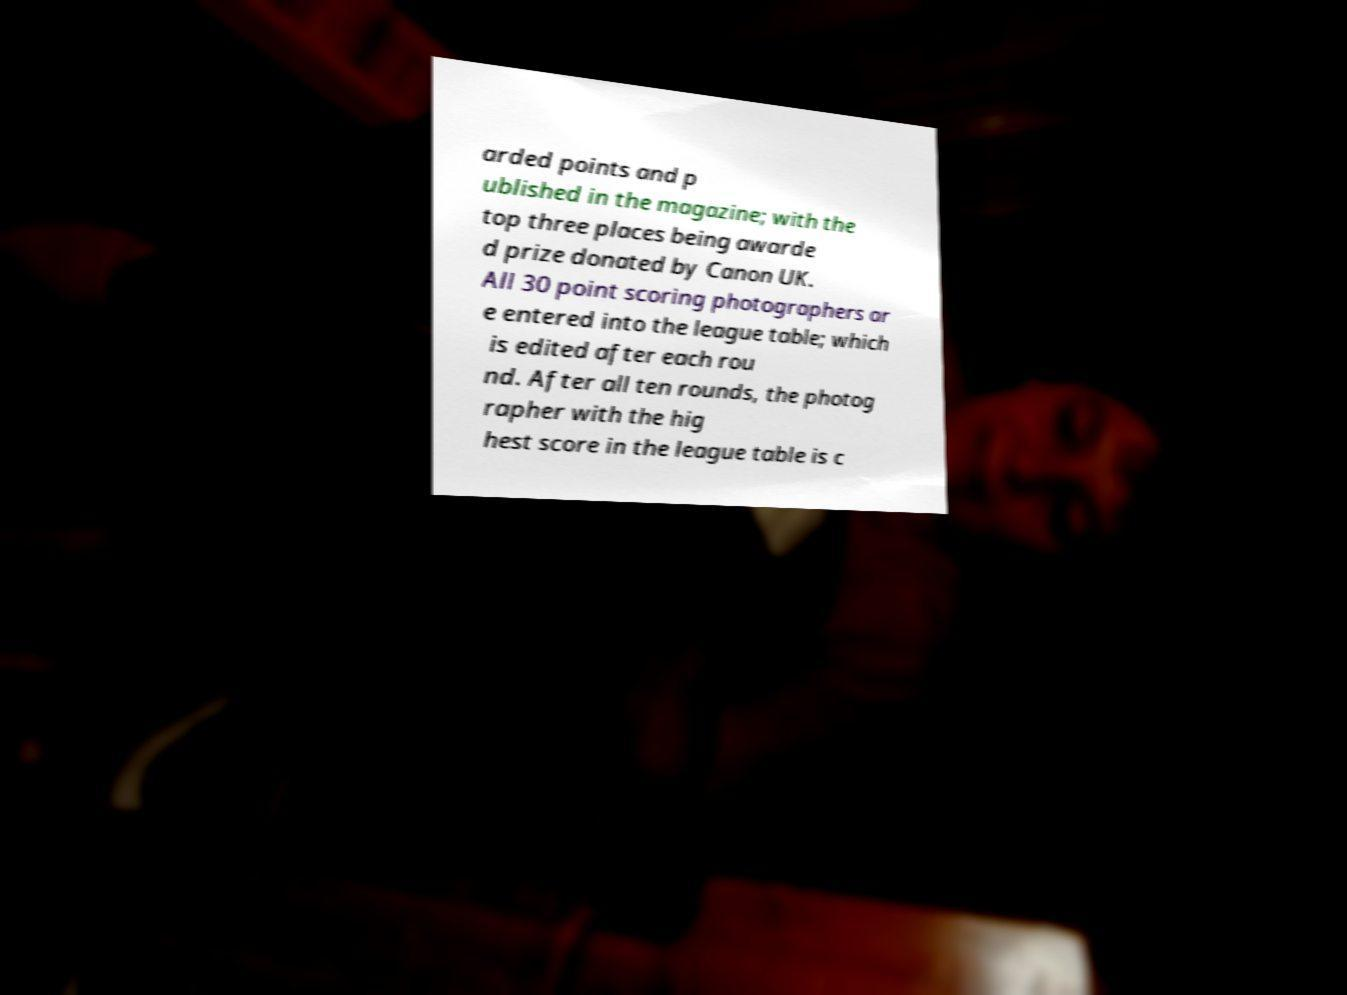Can you accurately transcribe the text from the provided image for me? arded points and p ublished in the magazine; with the top three places being awarde d prize donated by Canon UK. All 30 point scoring photographers ar e entered into the league table; which is edited after each rou nd. After all ten rounds, the photog rapher with the hig hest score in the league table is c 